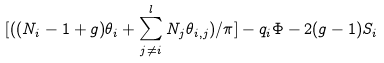Convert formula to latex. <formula><loc_0><loc_0><loc_500><loc_500>[ ( ( N _ { i } - 1 + g ) \theta _ { i } + \sum _ { j \not = i } ^ { l } N _ { j } \theta _ { i , j } ) / { \pi } ] - q _ { i } \Phi - 2 ( g - 1 ) S _ { i }</formula> 